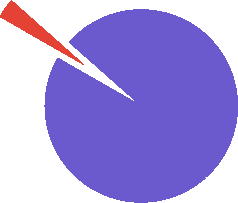<chart> <loc_0><loc_0><loc_500><loc_500><pie_chart><fcel>Taxes on income from<fcel>Credit to Stockholders' equity<nl><fcel>96.75%<fcel>3.25%<nl></chart> 